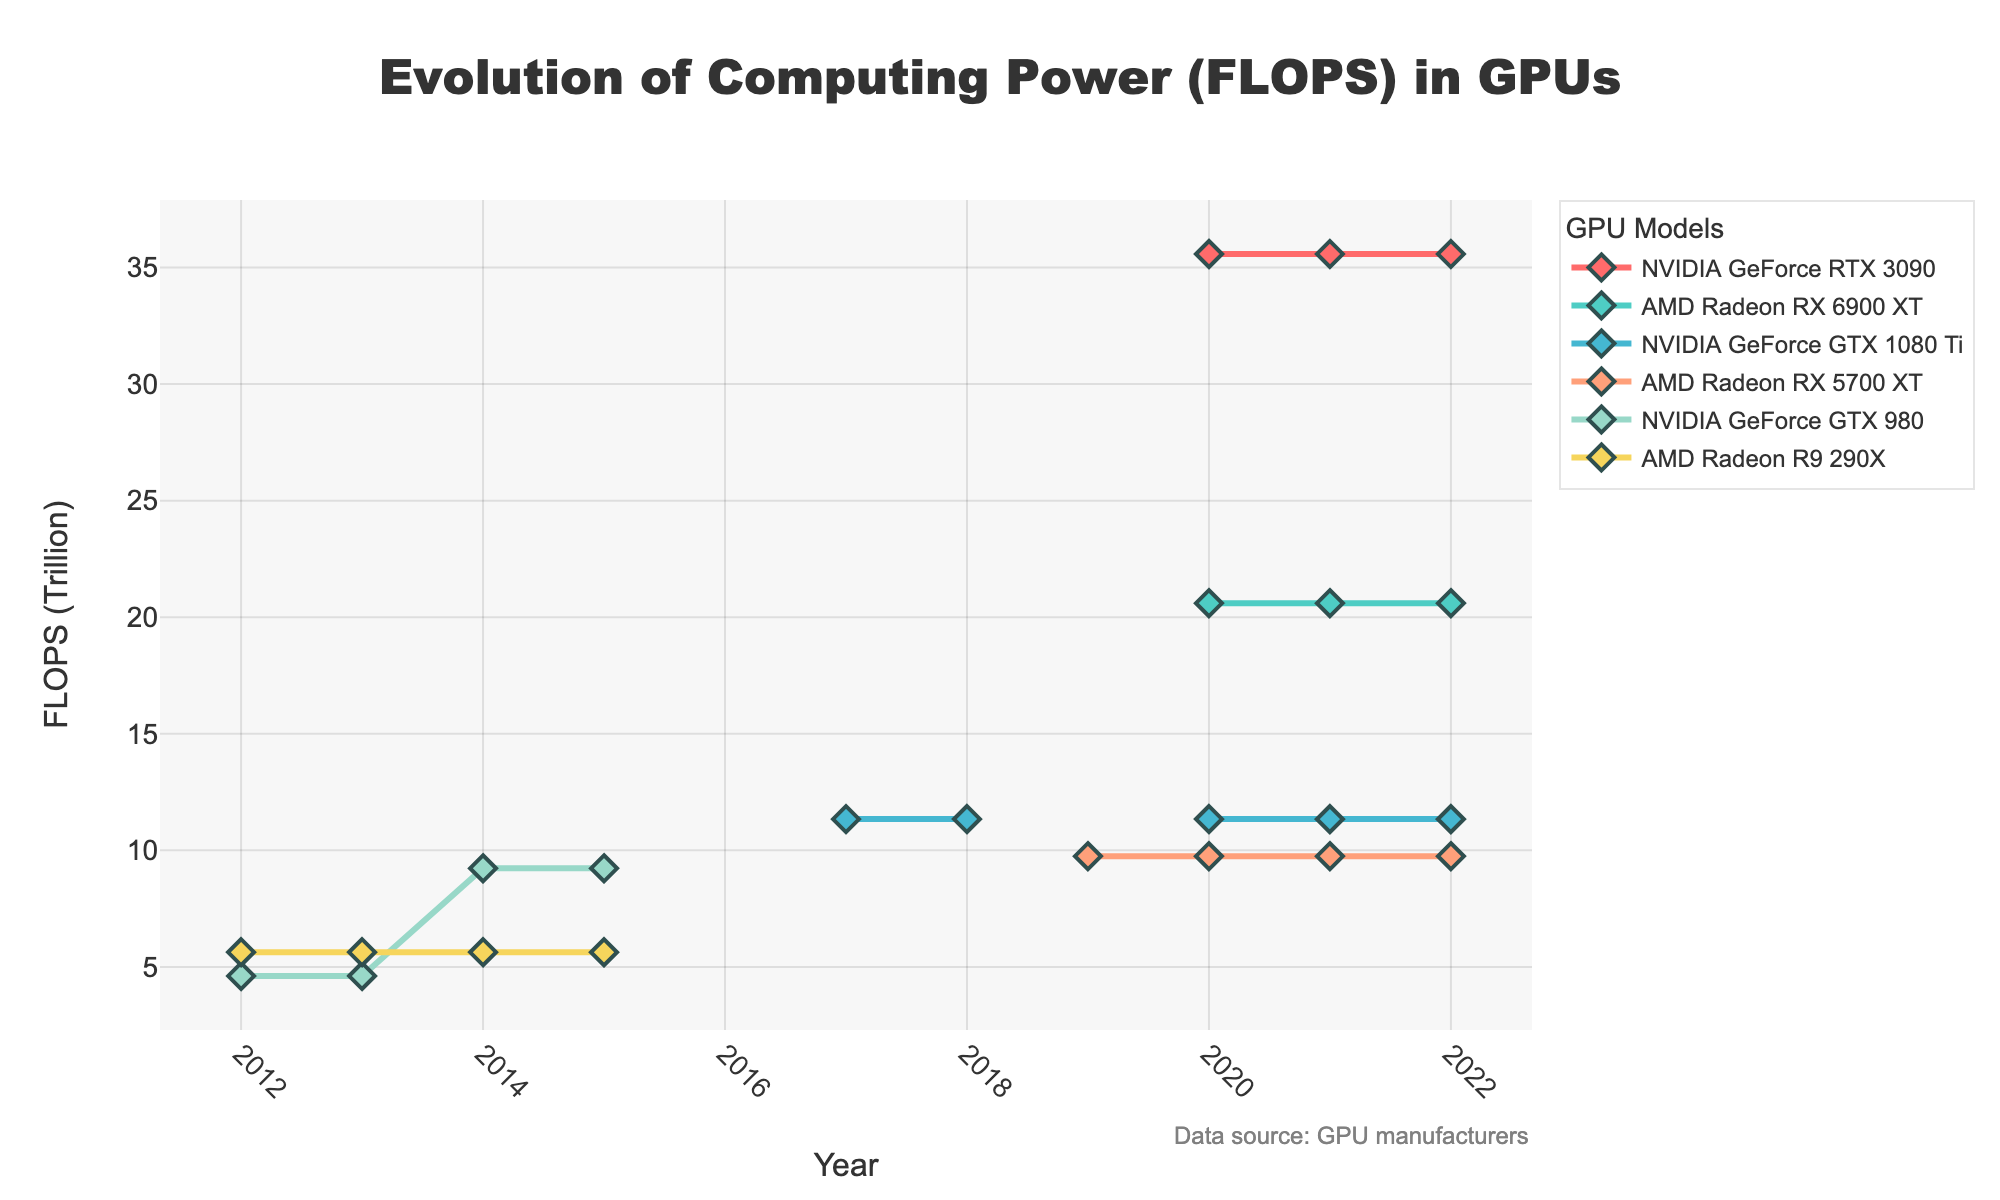Which GPU had the highest FLOPS in 2020? In the 2020 data points, compare the FLOPS values of all listed GPUs and identify the highest one. NVIDIA GeForce RTX 3090 shows a value of 35.58, which is the highest among the GPUs listed for 2020.
Answer: NVIDIA GeForce RTX 3090 How did the FLOPS of AMD Radeon RX 5700 XT change from 2019 to 2020? Compare the values for AMD Radeon RX 5700 XT in 2019 and 2020. It started with 9.75 in 2019 and remained the same in 2020.
Answer: No change Which GPU models were introduced in the plot in 2020? Scan through the plot to identify which GPU models first appear in the year 2020. NVIDIA GeForce RTX 3090 and AMD Radeon RX 6900 XT first appear in 2020 with values 35.58 and 20.6 respectively.
Answer: NVIDIA GeForce RTX 3090, AMD Radeon RX 6900 XT Between 2014 and 2015, did the FLOPS of NVIDIA GeForce GTX 980 change? Compare the FLOPS values of the NVIDIA GeForce GTX 980 in 2014 and 2015. The values for both years are 4.61, indicating no change.
Answer: No What is the difference in FLOPS between NVIDIA GeForce RTX 3090 and AMD Radeon RX 6900 XT in 2021? Subtract the FLOPS value of AMD Radeon RX 6900 XT from that of NVIDIA GeForce RTX 3090 in 2021: 35.58 - 20.6.
Answer: 14.98 Which GPU had the most significant increase in FLOPS from 2017 to 2020? Compare the changes in FLOPS for each GPU from 2017 to 2020. NVIDIA GeForce RTX 3090 shows an increase from non-existent (0) to 35.58, making it the most significant increase.
Answer: NVIDIA GeForce RTX 3090 What was the average FLOPS of NVIDIA GeForce GTX 1080 Ti across all years it was recorded? To calculate the average, sum the FLOPS values for NVIDIA GeForce GTX 1080 Ti across the years (2017, 2018, 2020, 2021, 2022) and then divide by the number of years. The sum is 11.34 + 11.34 + 11.34 + 11.34 + 11.34 which is 56.7. The number of years is 5. Thus, the average is 56.7 / 5.
Answer: 11.34 How did the FLOPS of AMD Radeon R9 290X evolve between 2012 and 2015? Look at the FLOPS values of AMD Radeon R9 290X for the years 2012 to 2015. The values show 5.63 for all years, indicating no change.
Answer: No change What is the total sum of FLOPS for NVIDIA GeForce GTX 980 across all available years? Sum the FLOPS values of NVIDIA GeForce GTX 980 for all the years it appears (2012, 2013, 2014, 2015). 4.61 + 4.61 + 9.23 + 9.23 = 27.68.
Answer: 27.68 